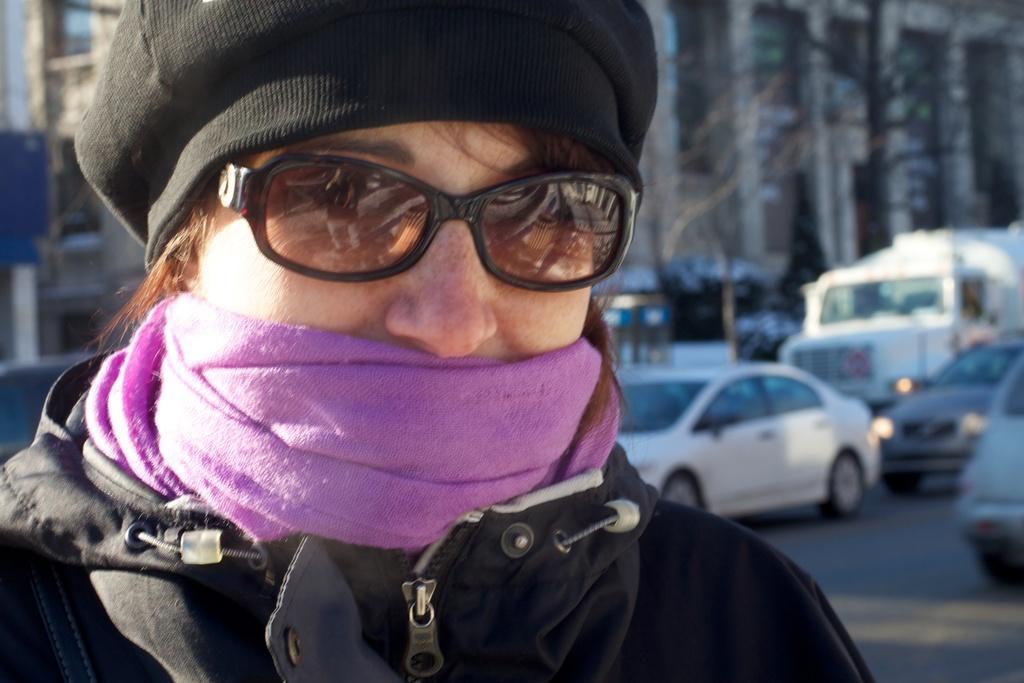How would you summarize this image in a sentence or two? This image is taken outdoors. On the right side of the image a few vehicles are moving on the road. On the left side of the image there is a person with a hat, a scarf, jacket and goggles. In this image the background is all little blurred. 